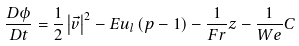<formula> <loc_0><loc_0><loc_500><loc_500>\frac { D \phi } { D t } = \frac { 1 } { 2 } \left | \vec { v } \right | ^ { 2 } - E u _ { l } \left ( p - 1 \right ) - \frac { 1 } { F r } z - \frac { 1 } { W e } C</formula> 